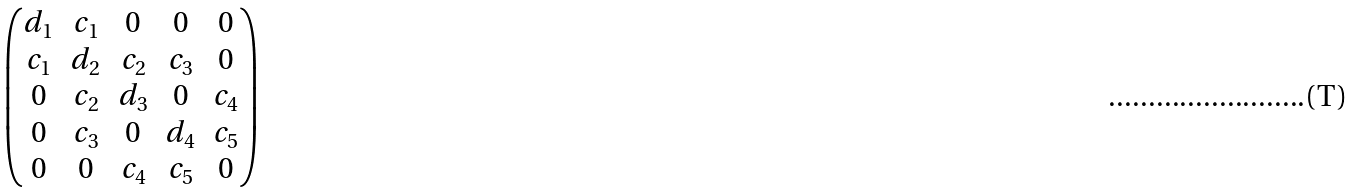Convert formula to latex. <formula><loc_0><loc_0><loc_500><loc_500>\begin{pmatrix} d _ { 1 } & c _ { 1 } & 0 & 0 & 0 \\ c _ { 1 } & d _ { 2 } & c _ { 2 } & c _ { 3 } & 0 \\ 0 & c _ { 2 } & d _ { 3 } & 0 & c _ { 4 } \\ 0 & c _ { 3 } & 0 & d _ { 4 } & c _ { 5 } \\ 0 & 0 & c _ { 4 } & c _ { 5 } & 0 \end{pmatrix}</formula> 